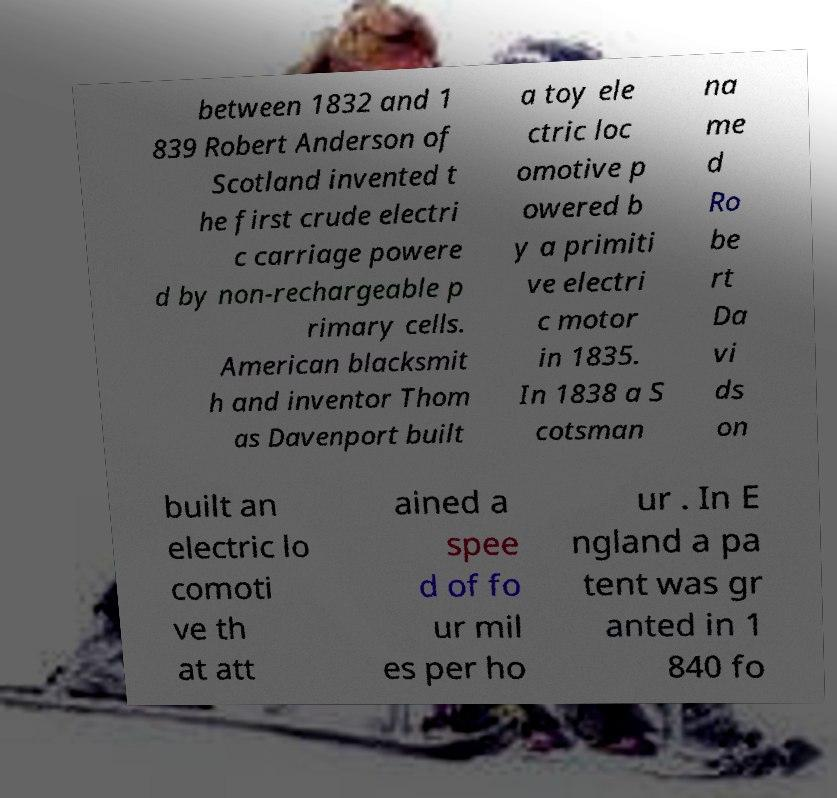Please read and relay the text visible in this image. What does it say? between 1832 and 1 839 Robert Anderson of Scotland invented t he first crude electri c carriage powere d by non-rechargeable p rimary cells. American blacksmit h and inventor Thom as Davenport built a toy ele ctric loc omotive p owered b y a primiti ve electri c motor in 1835. In 1838 a S cotsman na me d Ro be rt Da vi ds on built an electric lo comoti ve th at att ained a spee d of fo ur mil es per ho ur . In E ngland a pa tent was gr anted in 1 840 fo 